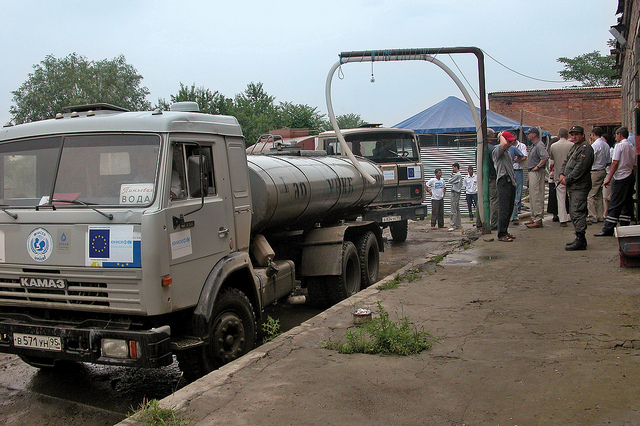<image>What color is the train? There is no train in the image. What color is the train? It is unanswerable what color the train is. There is no train in the image. 